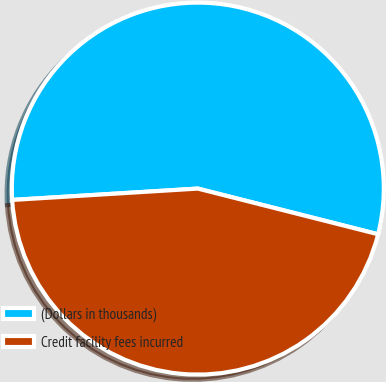<chart> <loc_0><loc_0><loc_500><loc_500><pie_chart><fcel>(Dollars in thousands)<fcel>Credit facility fees incurred<nl><fcel>54.92%<fcel>45.08%<nl></chart> 